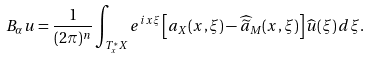Convert formula to latex. <formula><loc_0><loc_0><loc_500><loc_500>B _ { \alpha } u = \frac { 1 } { ( 2 \pi ) ^ { n } } \int _ { T ^ { * } _ { x } X } e ^ { i x \xi } \left [ a _ { X } ( x , \xi ) - \widehat { \widetilde { a } } _ { M } ( x , \xi ) \right ] \widehat { u } ( \xi ) \, d \xi .</formula> 